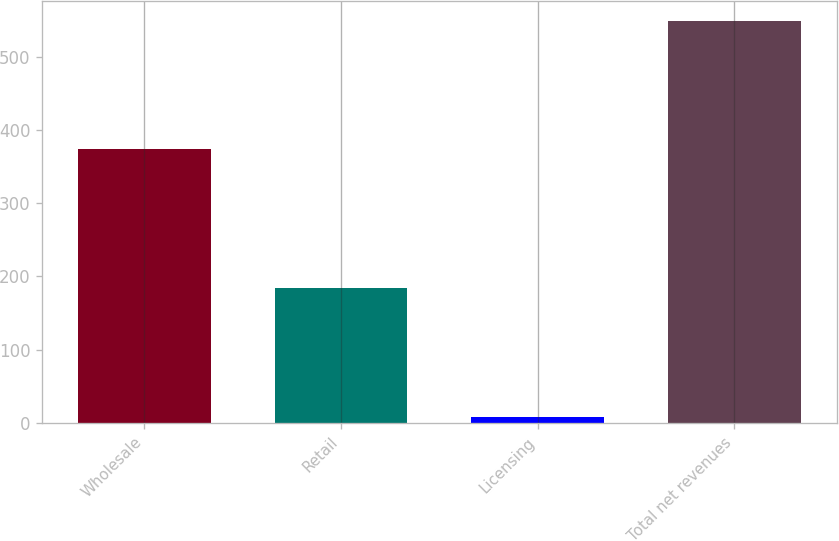<chart> <loc_0><loc_0><loc_500><loc_500><bar_chart><fcel>Wholesale<fcel>Retail<fcel>Licensing<fcel>Total net revenues<nl><fcel>373.4<fcel>184.6<fcel>8.9<fcel>549.1<nl></chart> 